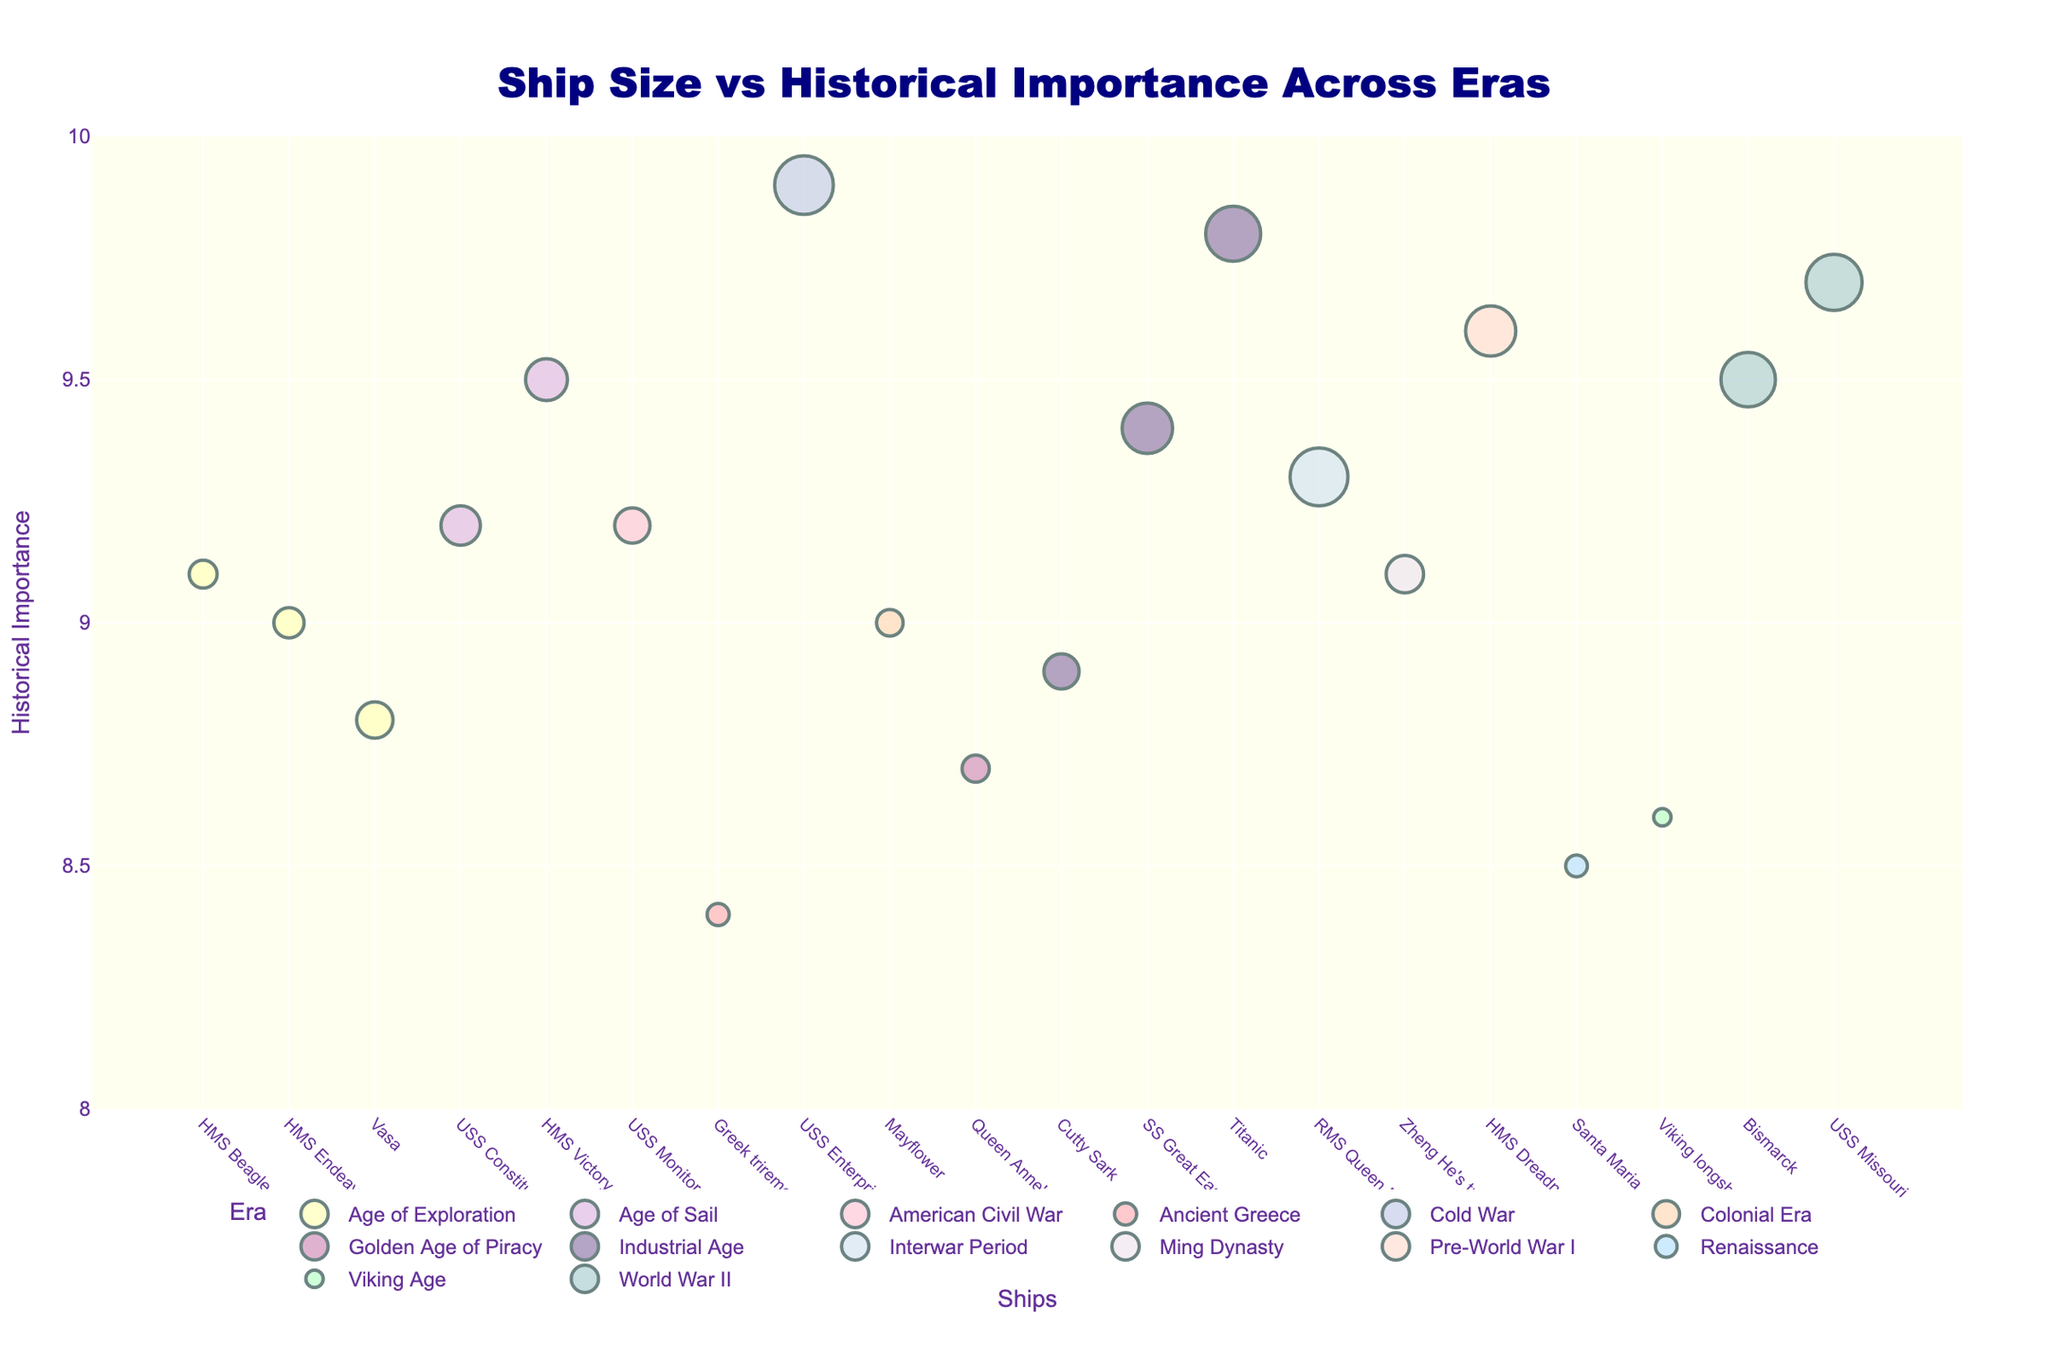What's the largest ship in the plot? To find the largest ship, look for the largest marker, since size is represented by the area of the markers. The largest marker belongs to "USS Enterprise (CVN-65)".
Answer: USS Enterprise (CVN-65) Which ship has the lowest historical importance in the plot? The y-axis represents historical importance, so find the marker positioned lowest. The lowest marker is for the "Greek trireme" with a historical importance of 8.4.
Answer: Greek trireme In which era is the "Titanic" placed? Find the marker labeled "Titanic" and look at its text hover information or the legend to identify the era color. "Titanic" is in the Industrial Age era.
Answer: Industrial Age Which ship from the Age of Sail era has the highest historical importance? Identify markers colored for the Age of Sail and compare their positions on the y-axis. The marker highest up is "HMS Victory" with a historical importance of 9.5.
Answer: HMS Victory How do the historical importance scores of "HMS Beagle" and "Mayflower" compare? Locate both markers and compare their y-axis values. "HMS Beagle" has a score of 9.1, while "Mayflower" has 9.0.
Answer: HMS Beagle > Mayflower What is the average historical importance score of ships from the World War II era? World War II ships are identified by their specific color. Calculate the average of their y-values: USS Missouri (9.7) and Bismarck (9.5). The average is (9.7 + 9.5) / 2 = 9.6.
Answer: 9.6 Which two eras have the most visually similar marker colors? Visually compare era colors in the legend to see which are closest in hue. "Age of Sail" and "American Civil War" have the most similar colors, both shades of purple and pink.
Answer: Age of Sail & American Civil War What is the total size metric for ships in the Industrial Age? Sum the size metric values for Industrial Age ships: Titanic (46328), Cutty Sark (963), SS Great Eastern (18915). The total is 46328 + 963 + 18915 = 66206.
Answer: 66206 